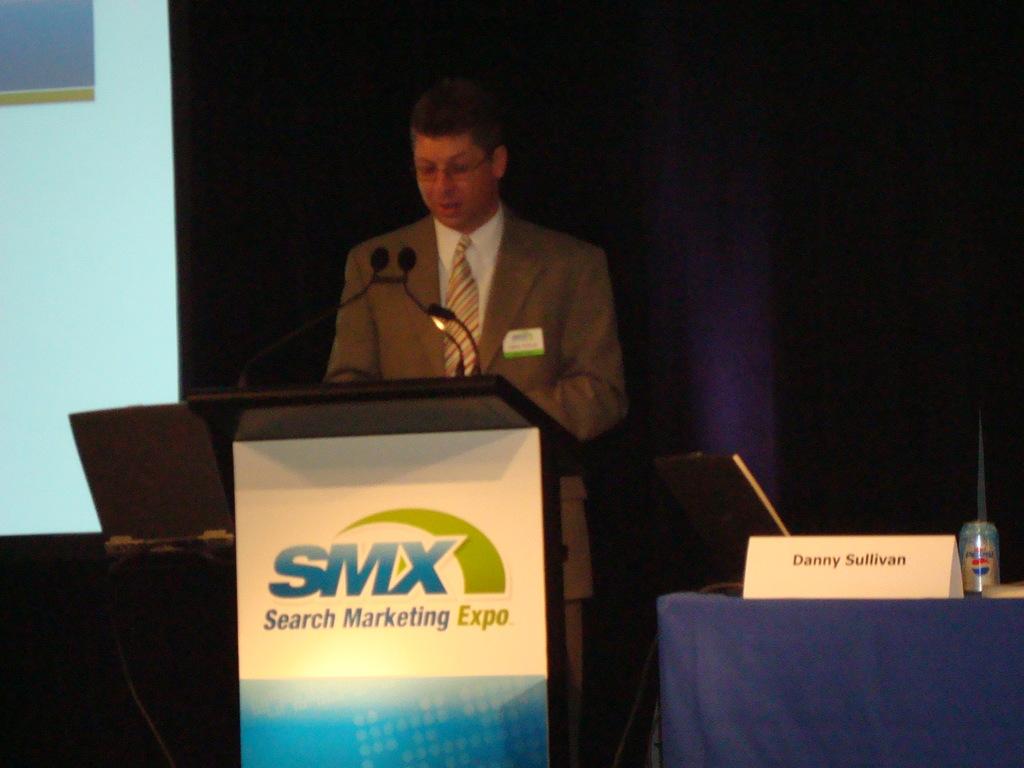What expo did this take place at?
Your answer should be compact. Search marketing expo. What does smx stand for?
Keep it short and to the point. Search marketing expo. 